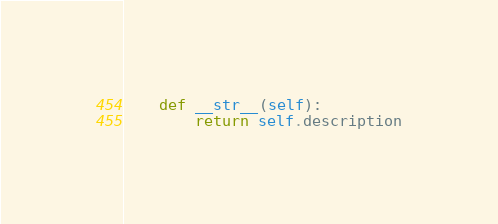<code> <loc_0><loc_0><loc_500><loc_500><_Python_>
    def __str__(self):
        return self.description</code> 